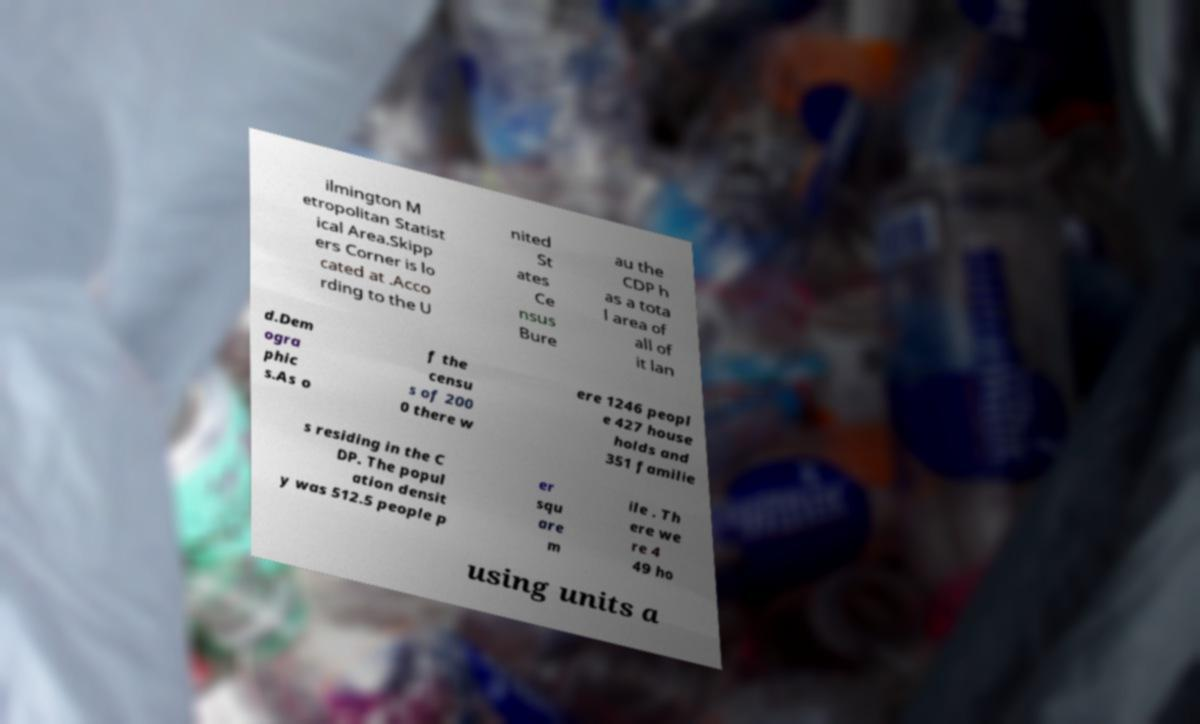Please identify and transcribe the text found in this image. ilmington M etropolitan Statist ical Area.Skipp ers Corner is lo cated at .Acco rding to the U nited St ates Ce nsus Bure au the CDP h as a tota l area of all of it lan d.Dem ogra phic s.As o f the censu s of 200 0 there w ere 1246 peopl e 427 house holds and 351 familie s residing in the C DP. The popul ation densit y was 512.5 people p er squ are m ile . Th ere we re 4 49 ho using units a 